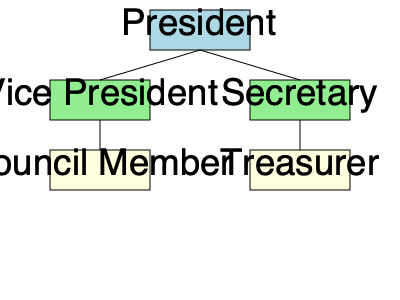Based on the organizational chart, who does the Council Member directly report to? To determine the reporting line for the Council Member, we need to follow these steps:

1. Identify the position of the Council Member in the chart.
   - The Council Member is located in the bottom left corner of the chart.

2. Look for the line connecting the Council Member to the position above it.
   - There is a vertical line connecting the Council Member to the Vice President.

3. Verify that there are no other direct connections to higher positions.
   - The Council Member does not have any direct lines to the President or Secretary.

4. Conclude the reporting structure based on the direct connection.
   - The Council Member is directly connected to the Vice President, indicating a direct reporting relationship.

Therefore, based on the organizational chart, the Council Member directly reports to the Vice President.
Answer: Vice President 